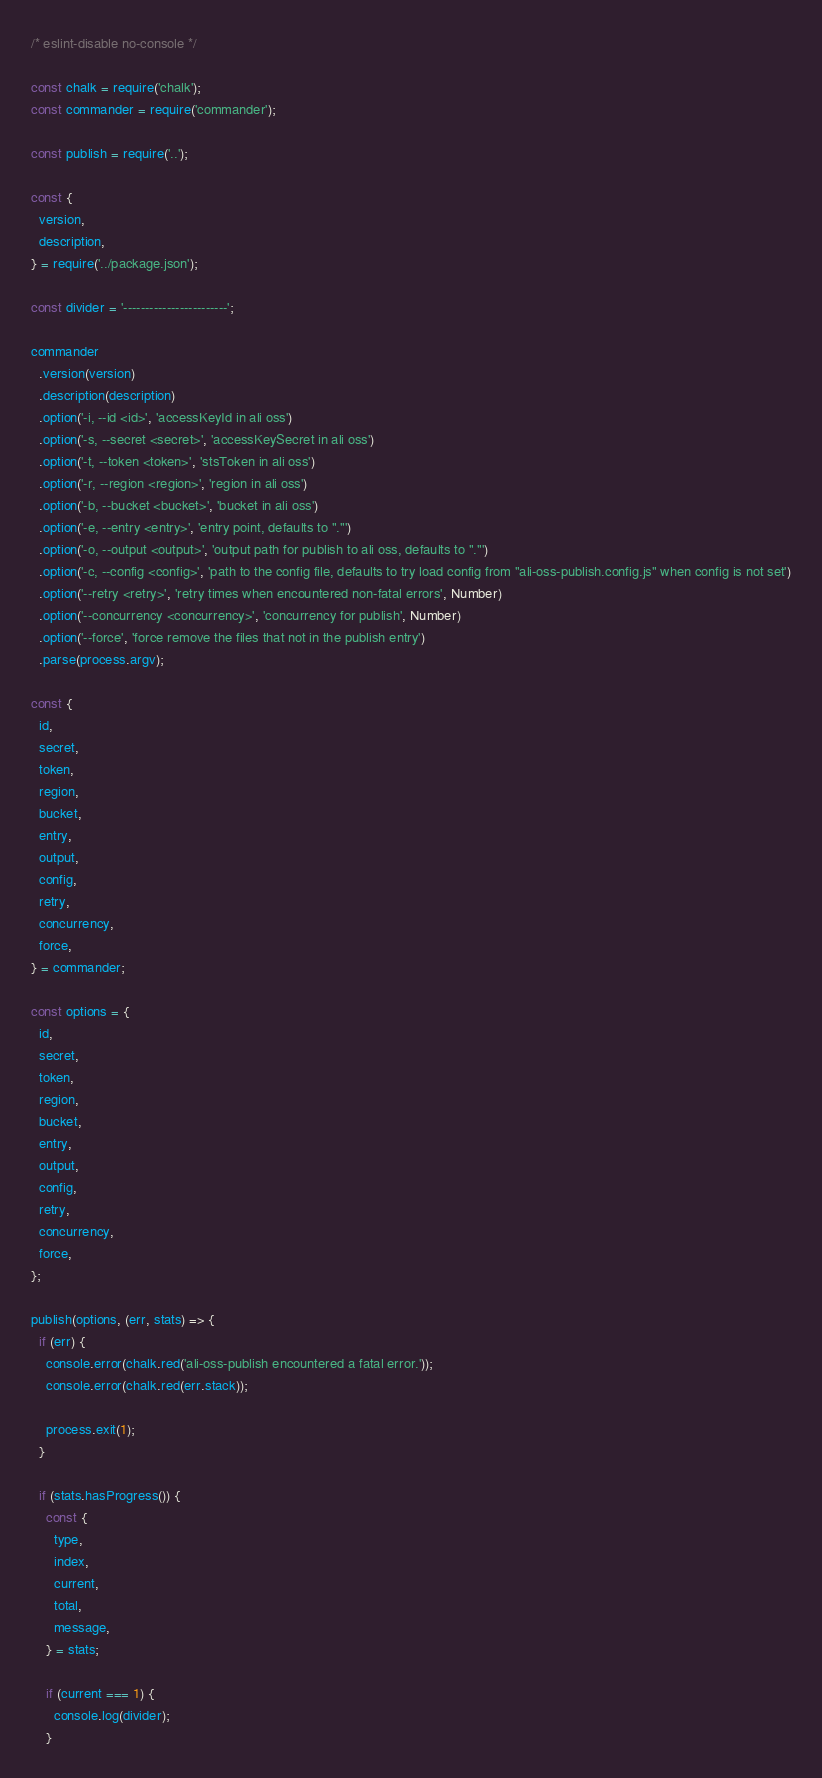<code> <loc_0><loc_0><loc_500><loc_500><_JavaScript_>/* eslint-disable no-console */

const chalk = require('chalk');
const commander = require('commander');

const publish = require('..');

const {
  version,
  description,
} = require('../package.json');

const divider = '------------------------';

commander
  .version(version)
  .description(description)
  .option('-i, --id <id>', 'accessKeyId in ali oss')
  .option('-s, --secret <secret>', 'accessKeySecret in ali oss')
  .option('-t, --token <token>', 'stsToken in ali oss')
  .option('-r, --region <region>', 'region in ali oss')
  .option('-b, --bucket <bucket>', 'bucket in ali oss')
  .option('-e, --entry <entry>', 'entry point, defaults to "."')
  .option('-o, --output <output>', 'output path for publish to ali oss, defaults to "."')
  .option('-c, --config <config>', 'path to the config file, defaults to try load config from "ali-oss-publish.config.js" when config is not set')
  .option('--retry <retry>', 'retry times when encountered non-fatal errors', Number)
  .option('--concurrency <concurrency>', 'concurrency for publish', Number)
  .option('--force', 'force remove the files that not in the publish entry')
  .parse(process.argv);

const {
  id,
  secret,
  token,
  region,
  bucket,
  entry,
  output,
  config,
  retry,
  concurrency,
  force,
} = commander;

const options = {
  id,
  secret,
  token,
  region,
  bucket,
  entry,
  output,
  config,
  retry,
  concurrency,
  force,
};

publish(options, (err, stats) => {
  if (err) {
    console.error(chalk.red('ali-oss-publish encountered a fatal error.'));
    console.error(chalk.red(err.stack));

    process.exit(1);
  }

  if (stats.hasProgress()) {
    const {
      type,
      index,
      current,
      total,
      message,
    } = stats;

    if (current === 1) {
      console.log(divider);
    }
</code> 